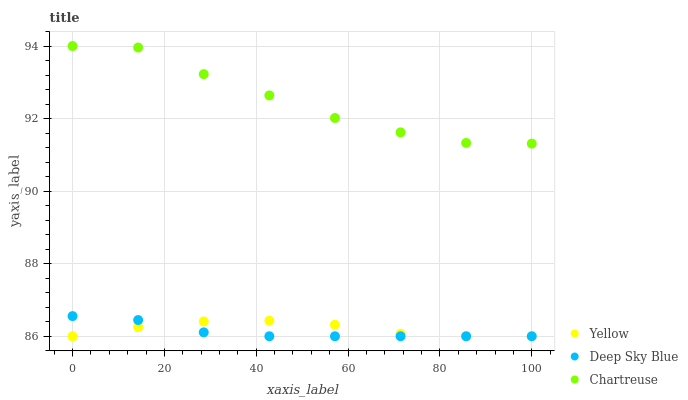Does Deep Sky Blue have the minimum area under the curve?
Answer yes or no. Yes. Does Chartreuse have the maximum area under the curve?
Answer yes or no. Yes. Does Yellow have the minimum area under the curve?
Answer yes or no. No. Does Yellow have the maximum area under the curve?
Answer yes or no. No. Is Deep Sky Blue the smoothest?
Answer yes or no. Yes. Is Chartreuse the roughest?
Answer yes or no. Yes. Is Yellow the smoothest?
Answer yes or no. No. Is Yellow the roughest?
Answer yes or no. No. Does Deep Sky Blue have the lowest value?
Answer yes or no. Yes. Does Chartreuse have the highest value?
Answer yes or no. Yes. Does Deep Sky Blue have the highest value?
Answer yes or no. No. Is Deep Sky Blue less than Chartreuse?
Answer yes or no. Yes. Is Chartreuse greater than Deep Sky Blue?
Answer yes or no. Yes. Does Deep Sky Blue intersect Yellow?
Answer yes or no. Yes. Is Deep Sky Blue less than Yellow?
Answer yes or no. No. Is Deep Sky Blue greater than Yellow?
Answer yes or no. No. Does Deep Sky Blue intersect Chartreuse?
Answer yes or no. No. 